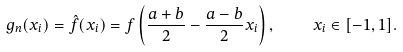Convert formula to latex. <formula><loc_0><loc_0><loc_500><loc_500>g _ { n } ( x _ { i } ) = \hat { f } ( x _ { i } ) = f \left ( \frac { a + b } { 2 } - \frac { a - b } { 2 } x _ { i } \right ) , \quad x _ { i } \in [ - 1 , 1 ] .</formula> 